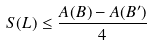<formula> <loc_0><loc_0><loc_500><loc_500>S ( L ) \leq \frac { A ( B ) - A ( B ^ { \prime } ) } { 4 }</formula> 